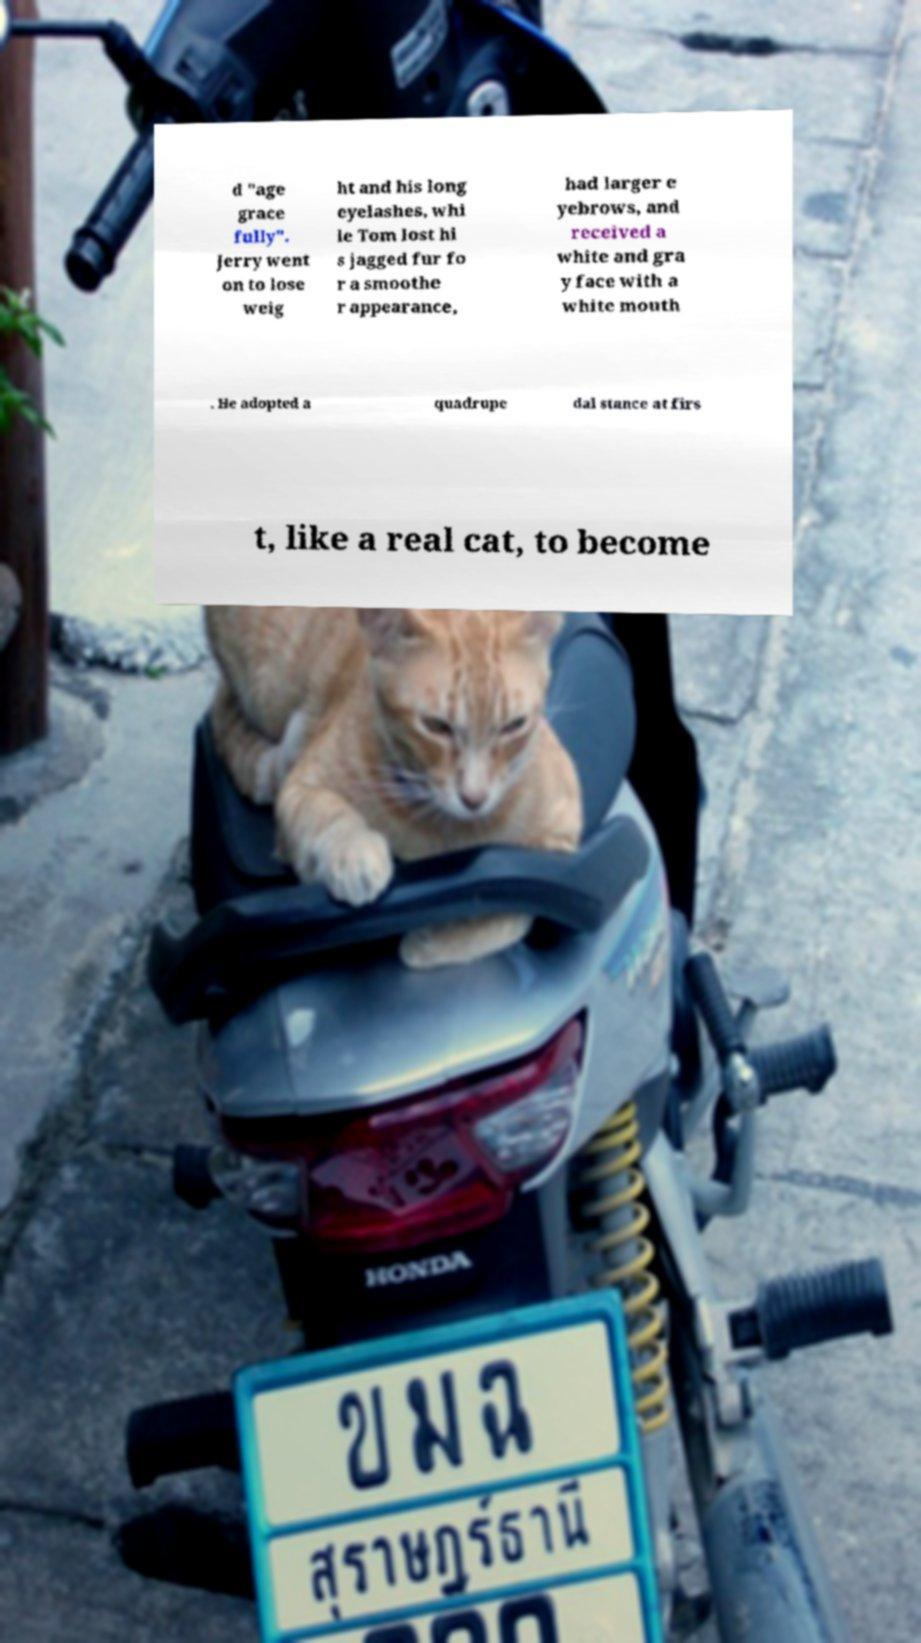For documentation purposes, I need the text within this image transcribed. Could you provide that? d "age grace fully". Jerry went on to lose weig ht and his long eyelashes, whi le Tom lost hi s jagged fur fo r a smoothe r appearance, had larger e yebrows, and received a white and gra y face with a white mouth . He adopted a quadrupe dal stance at firs t, like a real cat, to become 